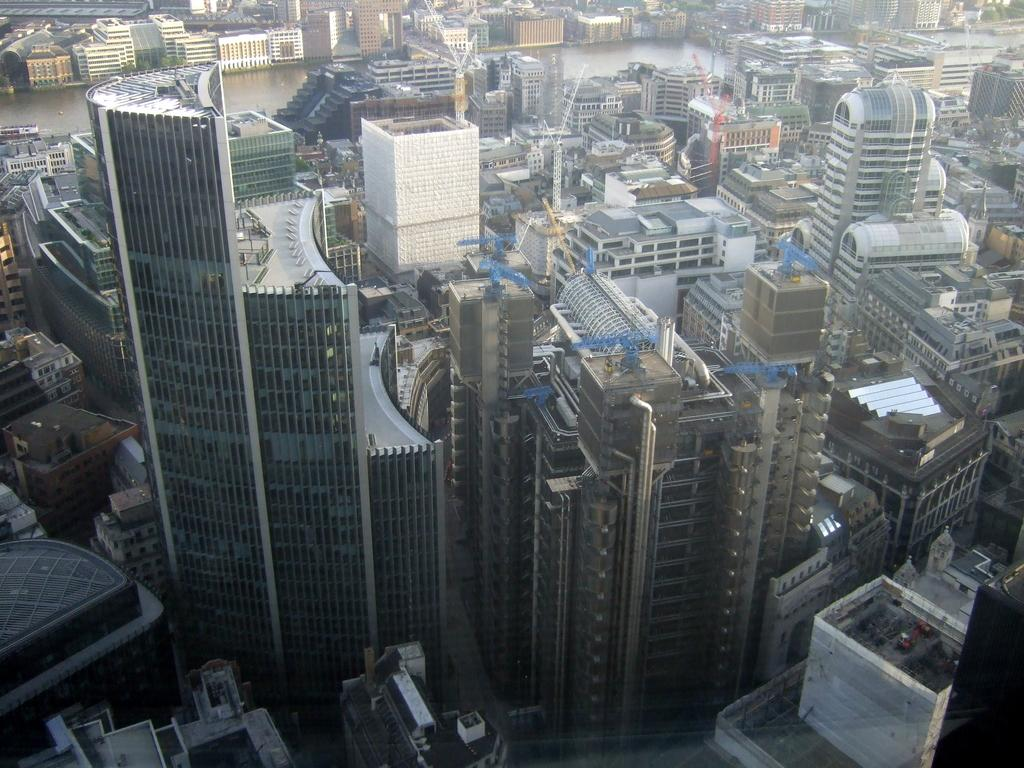What type of view is shown in the image? The image is an aerial view of a city. What can be seen in the foreground of the picture? There are skyscrapers and buildings in the foreground of the picture. What is visible in the background of the image? There is a water body in the background of the picture. What can be seen at the top of the image? There are buildings visible at the top of the image. What type of furniture is visible in the image? There is no furniture visible in the image, as it is an aerial view of a city with a focus on buildings and a water body. 